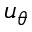<formula> <loc_0><loc_0><loc_500><loc_500>u _ { \theta }</formula> 